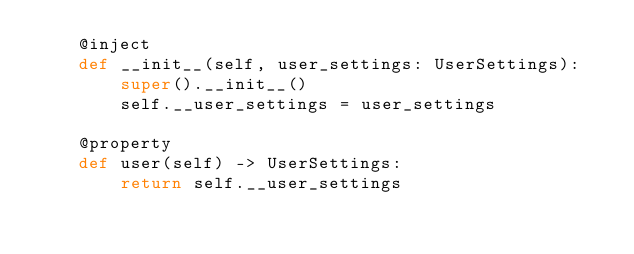Convert code to text. <code><loc_0><loc_0><loc_500><loc_500><_Python_>    @inject
    def __init__(self, user_settings: UserSettings):
        super().__init__()
        self.__user_settings = user_settings

    @property
    def user(self) -> UserSettings:
        return self.__user_settings
</code> 